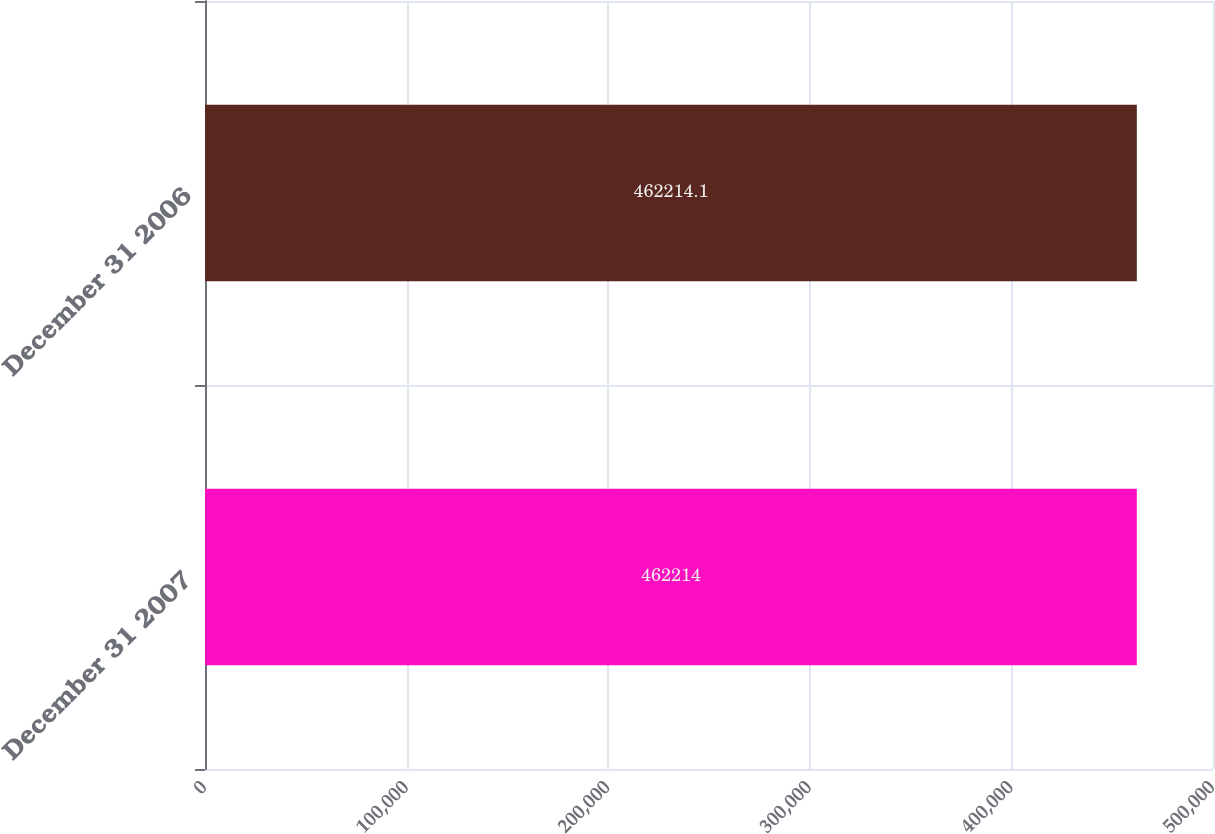Convert chart to OTSL. <chart><loc_0><loc_0><loc_500><loc_500><bar_chart><fcel>December 31 2007<fcel>December 31 2006<nl><fcel>462214<fcel>462214<nl></chart> 